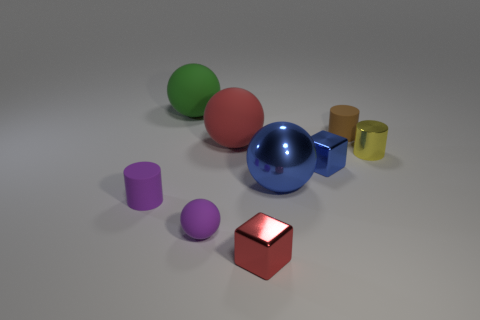Subtract all small rubber cylinders. How many cylinders are left? 1 Subtract all balls. How many objects are left? 5 Subtract all purple cylinders. How many cylinders are left? 2 Add 1 rubber things. How many objects exist? 10 Subtract 1 cubes. How many cubes are left? 1 Subtract all green cubes. Subtract all brown cylinders. How many cubes are left? 2 Subtract all blue spheres. How many gray cylinders are left? 0 Subtract all small matte cylinders. Subtract all brown rubber things. How many objects are left? 6 Add 5 small metal blocks. How many small metal blocks are left? 7 Add 8 big yellow objects. How many big yellow objects exist? 8 